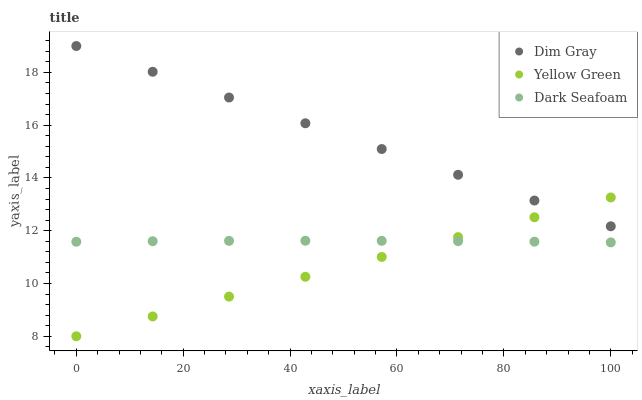Does Yellow Green have the minimum area under the curve?
Answer yes or no. Yes. Does Dim Gray have the maximum area under the curve?
Answer yes or no. Yes. Does Dim Gray have the minimum area under the curve?
Answer yes or no. No. Does Yellow Green have the maximum area under the curve?
Answer yes or no. No. Is Yellow Green the smoothest?
Answer yes or no. Yes. Is Dark Seafoam the roughest?
Answer yes or no. Yes. Is Dim Gray the smoothest?
Answer yes or no. No. Is Dim Gray the roughest?
Answer yes or no. No. Does Yellow Green have the lowest value?
Answer yes or no. Yes. Does Dim Gray have the lowest value?
Answer yes or no. No. Does Dim Gray have the highest value?
Answer yes or no. Yes. Does Yellow Green have the highest value?
Answer yes or no. No. Is Dark Seafoam less than Dim Gray?
Answer yes or no. Yes. Is Dim Gray greater than Dark Seafoam?
Answer yes or no. Yes. Does Dim Gray intersect Yellow Green?
Answer yes or no. Yes. Is Dim Gray less than Yellow Green?
Answer yes or no. No. Is Dim Gray greater than Yellow Green?
Answer yes or no. No. Does Dark Seafoam intersect Dim Gray?
Answer yes or no. No. 